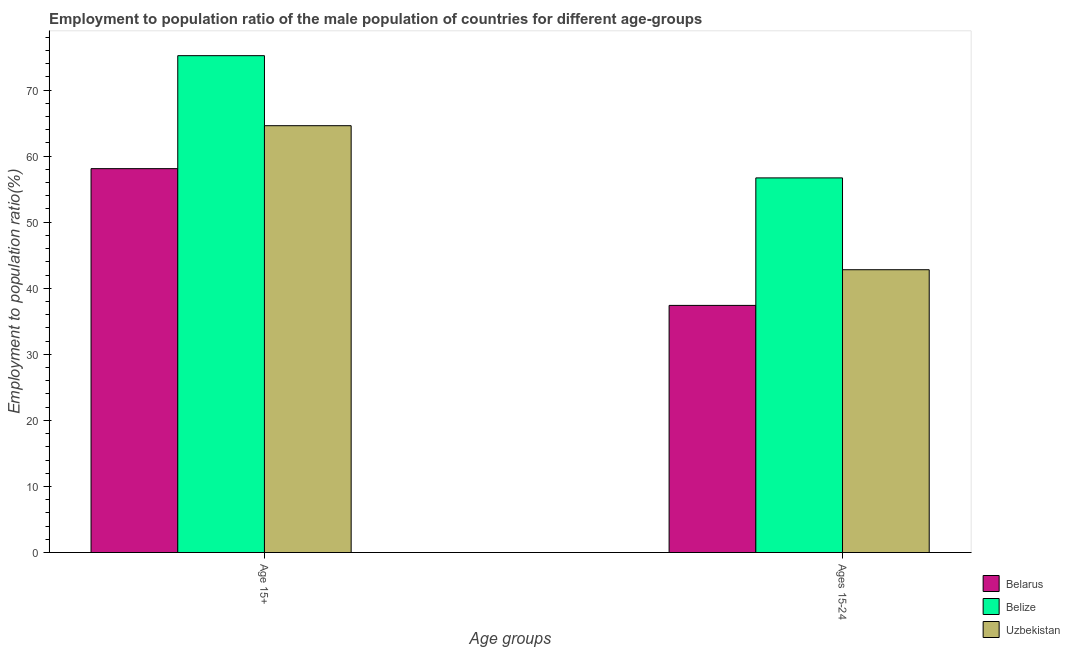How many different coloured bars are there?
Your response must be concise. 3. How many groups of bars are there?
Give a very brief answer. 2. What is the label of the 1st group of bars from the left?
Offer a very short reply. Age 15+. What is the employment to population ratio(age 15+) in Uzbekistan?
Keep it short and to the point. 64.6. Across all countries, what is the maximum employment to population ratio(age 15+)?
Your answer should be very brief. 75.2. Across all countries, what is the minimum employment to population ratio(age 15-24)?
Your answer should be compact. 37.4. In which country was the employment to population ratio(age 15-24) maximum?
Give a very brief answer. Belize. In which country was the employment to population ratio(age 15-24) minimum?
Offer a terse response. Belarus. What is the total employment to population ratio(age 15-24) in the graph?
Your answer should be very brief. 136.9. What is the difference between the employment to population ratio(age 15+) in Belarus and that in Belize?
Provide a succinct answer. -17.1. What is the difference between the employment to population ratio(age 15-24) in Belize and the employment to population ratio(age 15+) in Uzbekistan?
Keep it short and to the point. -7.9. What is the average employment to population ratio(age 15+) per country?
Provide a succinct answer. 65.97. What is the difference between the employment to population ratio(age 15-24) and employment to population ratio(age 15+) in Belarus?
Provide a succinct answer. -20.7. What is the ratio of the employment to population ratio(age 15+) in Belarus to that in Uzbekistan?
Give a very brief answer. 0.9. What does the 1st bar from the left in Age 15+ represents?
Keep it short and to the point. Belarus. What does the 2nd bar from the right in Age 15+ represents?
Your answer should be compact. Belize. How many bars are there?
Keep it short and to the point. 6. Does the graph contain any zero values?
Provide a short and direct response. No. Where does the legend appear in the graph?
Ensure brevity in your answer.  Bottom right. How are the legend labels stacked?
Offer a very short reply. Vertical. What is the title of the graph?
Your answer should be compact. Employment to population ratio of the male population of countries for different age-groups. What is the label or title of the X-axis?
Provide a succinct answer. Age groups. What is the label or title of the Y-axis?
Offer a terse response. Employment to population ratio(%). What is the Employment to population ratio(%) in Belarus in Age 15+?
Keep it short and to the point. 58.1. What is the Employment to population ratio(%) of Belize in Age 15+?
Give a very brief answer. 75.2. What is the Employment to population ratio(%) in Uzbekistan in Age 15+?
Offer a very short reply. 64.6. What is the Employment to population ratio(%) in Belarus in Ages 15-24?
Offer a terse response. 37.4. What is the Employment to population ratio(%) in Belize in Ages 15-24?
Ensure brevity in your answer.  56.7. What is the Employment to population ratio(%) in Uzbekistan in Ages 15-24?
Ensure brevity in your answer.  42.8. Across all Age groups, what is the maximum Employment to population ratio(%) of Belarus?
Your answer should be compact. 58.1. Across all Age groups, what is the maximum Employment to population ratio(%) in Belize?
Your response must be concise. 75.2. Across all Age groups, what is the maximum Employment to population ratio(%) in Uzbekistan?
Give a very brief answer. 64.6. Across all Age groups, what is the minimum Employment to population ratio(%) in Belarus?
Offer a very short reply. 37.4. Across all Age groups, what is the minimum Employment to population ratio(%) of Belize?
Offer a terse response. 56.7. Across all Age groups, what is the minimum Employment to population ratio(%) in Uzbekistan?
Ensure brevity in your answer.  42.8. What is the total Employment to population ratio(%) of Belarus in the graph?
Make the answer very short. 95.5. What is the total Employment to population ratio(%) of Belize in the graph?
Make the answer very short. 131.9. What is the total Employment to population ratio(%) of Uzbekistan in the graph?
Your answer should be very brief. 107.4. What is the difference between the Employment to population ratio(%) of Belarus in Age 15+ and that in Ages 15-24?
Provide a succinct answer. 20.7. What is the difference between the Employment to population ratio(%) of Belize in Age 15+ and that in Ages 15-24?
Your response must be concise. 18.5. What is the difference between the Employment to population ratio(%) of Uzbekistan in Age 15+ and that in Ages 15-24?
Make the answer very short. 21.8. What is the difference between the Employment to population ratio(%) in Belarus in Age 15+ and the Employment to population ratio(%) in Belize in Ages 15-24?
Your answer should be compact. 1.4. What is the difference between the Employment to population ratio(%) of Belarus in Age 15+ and the Employment to population ratio(%) of Uzbekistan in Ages 15-24?
Your answer should be compact. 15.3. What is the difference between the Employment to population ratio(%) of Belize in Age 15+ and the Employment to population ratio(%) of Uzbekistan in Ages 15-24?
Make the answer very short. 32.4. What is the average Employment to population ratio(%) in Belarus per Age groups?
Provide a succinct answer. 47.75. What is the average Employment to population ratio(%) in Belize per Age groups?
Make the answer very short. 65.95. What is the average Employment to population ratio(%) of Uzbekistan per Age groups?
Your response must be concise. 53.7. What is the difference between the Employment to population ratio(%) of Belarus and Employment to population ratio(%) of Belize in Age 15+?
Ensure brevity in your answer.  -17.1. What is the difference between the Employment to population ratio(%) of Belarus and Employment to population ratio(%) of Belize in Ages 15-24?
Your answer should be very brief. -19.3. What is the difference between the Employment to population ratio(%) in Belarus and Employment to population ratio(%) in Uzbekistan in Ages 15-24?
Offer a very short reply. -5.4. What is the ratio of the Employment to population ratio(%) in Belarus in Age 15+ to that in Ages 15-24?
Provide a succinct answer. 1.55. What is the ratio of the Employment to population ratio(%) in Belize in Age 15+ to that in Ages 15-24?
Provide a short and direct response. 1.33. What is the ratio of the Employment to population ratio(%) in Uzbekistan in Age 15+ to that in Ages 15-24?
Your answer should be compact. 1.51. What is the difference between the highest and the second highest Employment to population ratio(%) of Belarus?
Your response must be concise. 20.7. What is the difference between the highest and the second highest Employment to population ratio(%) in Belize?
Offer a terse response. 18.5. What is the difference between the highest and the second highest Employment to population ratio(%) in Uzbekistan?
Ensure brevity in your answer.  21.8. What is the difference between the highest and the lowest Employment to population ratio(%) of Belarus?
Your response must be concise. 20.7. What is the difference between the highest and the lowest Employment to population ratio(%) of Uzbekistan?
Your answer should be very brief. 21.8. 